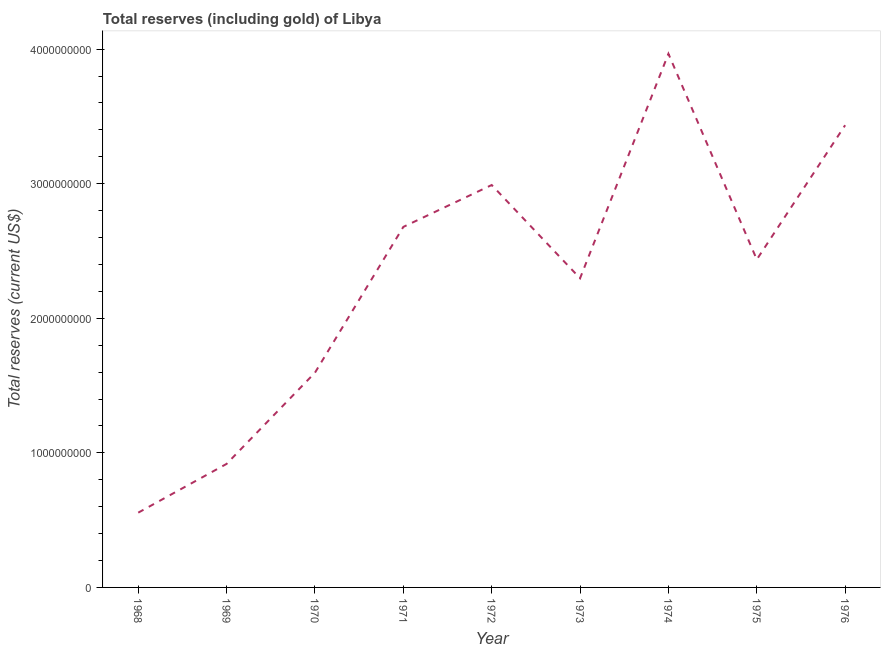What is the total reserves (including gold) in 1968?
Offer a terse response. 5.56e+08. Across all years, what is the maximum total reserves (including gold)?
Provide a short and direct response. 3.97e+09. Across all years, what is the minimum total reserves (including gold)?
Your answer should be very brief. 5.56e+08. In which year was the total reserves (including gold) maximum?
Keep it short and to the point. 1974. In which year was the total reserves (including gold) minimum?
Make the answer very short. 1968. What is the sum of the total reserves (including gold)?
Your answer should be very brief. 2.09e+1. What is the difference between the total reserves (including gold) in 1974 and 1976?
Your response must be concise. 5.31e+08. What is the average total reserves (including gold) per year?
Offer a terse response. 2.32e+09. What is the median total reserves (including gold)?
Provide a succinct answer. 2.44e+09. What is the ratio of the total reserves (including gold) in 1968 to that in 1972?
Give a very brief answer. 0.19. Is the total reserves (including gold) in 1969 less than that in 1973?
Provide a succinct answer. Yes. Is the difference between the total reserves (including gold) in 1971 and 1975 greater than the difference between any two years?
Keep it short and to the point. No. What is the difference between the highest and the second highest total reserves (including gold)?
Give a very brief answer. 5.31e+08. Is the sum of the total reserves (including gold) in 1969 and 1975 greater than the maximum total reserves (including gold) across all years?
Offer a very short reply. No. What is the difference between the highest and the lowest total reserves (including gold)?
Make the answer very short. 3.41e+09. In how many years, is the total reserves (including gold) greater than the average total reserves (including gold) taken over all years?
Your response must be concise. 5. What is the difference between two consecutive major ticks on the Y-axis?
Your response must be concise. 1.00e+09. Are the values on the major ticks of Y-axis written in scientific E-notation?
Ensure brevity in your answer.  No. What is the title of the graph?
Ensure brevity in your answer.  Total reserves (including gold) of Libya. What is the label or title of the Y-axis?
Offer a terse response. Total reserves (current US$). What is the Total reserves (current US$) in 1968?
Provide a succinct answer. 5.56e+08. What is the Total reserves (current US$) in 1969?
Give a very brief answer. 9.18e+08. What is the Total reserves (current US$) of 1970?
Provide a succinct answer. 1.60e+09. What is the Total reserves (current US$) of 1971?
Provide a short and direct response. 2.68e+09. What is the Total reserves (current US$) in 1972?
Your response must be concise. 2.99e+09. What is the Total reserves (current US$) in 1973?
Your answer should be very brief. 2.30e+09. What is the Total reserves (current US$) in 1974?
Make the answer very short. 3.97e+09. What is the Total reserves (current US$) of 1975?
Offer a terse response. 2.44e+09. What is the Total reserves (current US$) in 1976?
Provide a succinct answer. 3.43e+09. What is the difference between the Total reserves (current US$) in 1968 and 1969?
Keep it short and to the point. -3.62e+08. What is the difference between the Total reserves (current US$) in 1968 and 1970?
Provide a short and direct response. -1.04e+09. What is the difference between the Total reserves (current US$) in 1968 and 1971?
Offer a very short reply. -2.12e+09. What is the difference between the Total reserves (current US$) in 1968 and 1972?
Your answer should be compact. -2.43e+09. What is the difference between the Total reserves (current US$) in 1968 and 1973?
Offer a terse response. -1.74e+09. What is the difference between the Total reserves (current US$) in 1968 and 1974?
Provide a succinct answer. -3.41e+09. What is the difference between the Total reserves (current US$) in 1968 and 1975?
Provide a short and direct response. -1.88e+09. What is the difference between the Total reserves (current US$) in 1968 and 1976?
Ensure brevity in your answer.  -2.88e+09. What is the difference between the Total reserves (current US$) in 1969 and 1970?
Ensure brevity in your answer.  -6.78e+08. What is the difference between the Total reserves (current US$) in 1969 and 1971?
Make the answer very short. -1.76e+09. What is the difference between the Total reserves (current US$) in 1969 and 1972?
Your response must be concise. -2.07e+09. What is the difference between the Total reserves (current US$) in 1969 and 1973?
Make the answer very short. -1.38e+09. What is the difference between the Total reserves (current US$) in 1969 and 1974?
Keep it short and to the point. -3.05e+09. What is the difference between the Total reserves (current US$) in 1969 and 1975?
Your response must be concise. -1.52e+09. What is the difference between the Total reserves (current US$) in 1969 and 1976?
Make the answer very short. -2.52e+09. What is the difference between the Total reserves (current US$) in 1970 and 1971?
Your answer should be very brief. -1.08e+09. What is the difference between the Total reserves (current US$) in 1970 and 1972?
Offer a very short reply. -1.39e+09. What is the difference between the Total reserves (current US$) in 1970 and 1973?
Provide a short and direct response. -7.01e+08. What is the difference between the Total reserves (current US$) in 1970 and 1974?
Your response must be concise. -2.37e+09. What is the difference between the Total reserves (current US$) in 1970 and 1975?
Offer a very short reply. -8.41e+08. What is the difference between the Total reserves (current US$) in 1970 and 1976?
Keep it short and to the point. -1.84e+09. What is the difference between the Total reserves (current US$) in 1971 and 1972?
Keep it short and to the point. -3.11e+08. What is the difference between the Total reserves (current US$) in 1971 and 1973?
Provide a succinct answer. 3.82e+08. What is the difference between the Total reserves (current US$) in 1971 and 1974?
Give a very brief answer. -1.29e+09. What is the difference between the Total reserves (current US$) in 1971 and 1975?
Ensure brevity in your answer.  2.42e+08. What is the difference between the Total reserves (current US$) in 1971 and 1976?
Your answer should be compact. -7.56e+08. What is the difference between the Total reserves (current US$) in 1972 and 1973?
Your answer should be compact. 6.93e+08. What is the difference between the Total reserves (current US$) in 1972 and 1974?
Your response must be concise. -9.75e+08. What is the difference between the Total reserves (current US$) in 1972 and 1975?
Ensure brevity in your answer.  5.53e+08. What is the difference between the Total reserves (current US$) in 1972 and 1976?
Offer a very short reply. -4.45e+08. What is the difference between the Total reserves (current US$) in 1973 and 1974?
Your answer should be compact. -1.67e+09. What is the difference between the Total reserves (current US$) in 1973 and 1975?
Ensure brevity in your answer.  -1.40e+08. What is the difference between the Total reserves (current US$) in 1973 and 1976?
Offer a terse response. -1.14e+09. What is the difference between the Total reserves (current US$) in 1974 and 1975?
Give a very brief answer. 1.53e+09. What is the difference between the Total reserves (current US$) in 1974 and 1976?
Your response must be concise. 5.31e+08. What is the difference between the Total reserves (current US$) in 1975 and 1976?
Ensure brevity in your answer.  -9.98e+08. What is the ratio of the Total reserves (current US$) in 1968 to that in 1969?
Offer a very short reply. 0.6. What is the ratio of the Total reserves (current US$) in 1968 to that in 1970?
Your response must be concise. 0.35. What is the ratio of the Total reserves (current US$) in 1968 to that in 1971?
Your response must be concise. 0.21. What is the ratio of the Total reserves (current US$) in 1968 to that in 1972?
Provide a succinct answer. 0.19. What is the ratio of the Total reserves (current US$) in 1968 to that in 1973?
Give a very brief answer. 0.24. What is the ratio of the Total reserves (current US$) in 1968 to that in 1974?
Offer a terse response. 0.14. What is the ratio of the Total reserves (current US$) in 1968 to that in 1975?
Provide a short and direct response. 0.23. What is the ratio of the Total reserves (current US$) in 1968 to that in 1976?
Your answer should be very brief. 0.16. What is the ratio of the Total reserves (current US$) in 1969 to that in 1970?
Provide a succinct answer. 0.57. What is the ratio of the Total reserves (current US$) in 1969 to that in 1971?
Make the answer very short. 0.34. What is the ratio of the Total reserves (current US$) in 1969 to that in 1972?
Your answer should be compact. 0.31. What is the ratio of the Total reserves (current US$) in 1969 to that in 1973?
Your answer should be very brief. 0.4. What is the ratio of the Total reserves (current US$) in 1969 to that in 1974?
Your answer should be very brief. 0.23. What is the ratio of the Total reserves (current US$) in 1969 to that in 1975?
Your answer should be very brief. 0.38. What is the ratio of the Total reserves (current US$) in 1969 to that in 1976?
Offer a terse response. 0.27. What is the ratio of the Total reserves (current US$) in 1970 to that in 1971?
Ensure brevity in your answer.  0.6. What is the ratio of the Total reserves (current US$) in 1970 to that in 1972?
Provide a short and direct response. 0.53. What is the ratio of the Total reserves (current US$) in 1970 to that in 1973?
Give a very brief answer. 0.69. What is the ratio of the Total reserves (current US$) in 1970 to that in 1974?
Ensure brevity in your answer.  0.4. What is the ratio of the Total reserves (current US$) in 1970 to that in 1975?
Your answer should be compact. 0.66. What is the ratio of the Total reserves (current US$) in 1970 to that in 1976?
Your response must be concise. 0.47. What is the ratio of the Total reserves (current US$) in 1971 to that in 1972?
Make the answer very short. 0.9. What is the ratio of the Total reserves (current US$) in 1971 to that in 1973?
Your answer should be compact. 1.17. What is the ratio of the Total reserves (current US$) in 1971 to that in 1974?
Give a very brief answer. 0.68. What is the ratio of the Total reserves (current US$) in 1971 to that in 1975?
Give a very brief answer. 1.1. What is the ratio of the Total reserves (current US$) in 1971 to that in 1976?
Provide a succinct answer. 0.78. What is the ratio of the Total reserves (current US$) in 1972 to that in 1973?
Ensure brevity in your answer.  1.3. What is the ratio of the Total reserves (current US$) in 1972 to that in 1974?
Keep it short and to the point. 0.75. What is the ratio of the Total reserves (current US$) in 1972 to that in 1975?
Your response must be concise. 1.23. What is the ratio of the Total reserves (current US$) in 1972 to that in 1976?
Provide a short and direct response. 0.87. What is the ratio of the Total reserves (current US$) in 1973 to that in 1974?
Ensure brevity in your answer.  0.58. What is the ratio of the Total reserves (current US$) in 1973 to that in 1975?
Give a very brief answer. 0.94. What is the ratio of the Total reserves (current US$) in 1973 to that in 1976?
Ensure brevity in your answer.  0.67. What is the ratio of the Total reserves (current US$) in 1974 to that in 1975?
Your answer should be compact. 1.63. What is the ratio of the Total reserves (current US$) in 1974 to that in 1976?
Provide a short and direct response. 1.16. What is the ratio of the Total reserves (current US$) in 1975 to that in 1976?
Your answer should be compact. 0.71. 